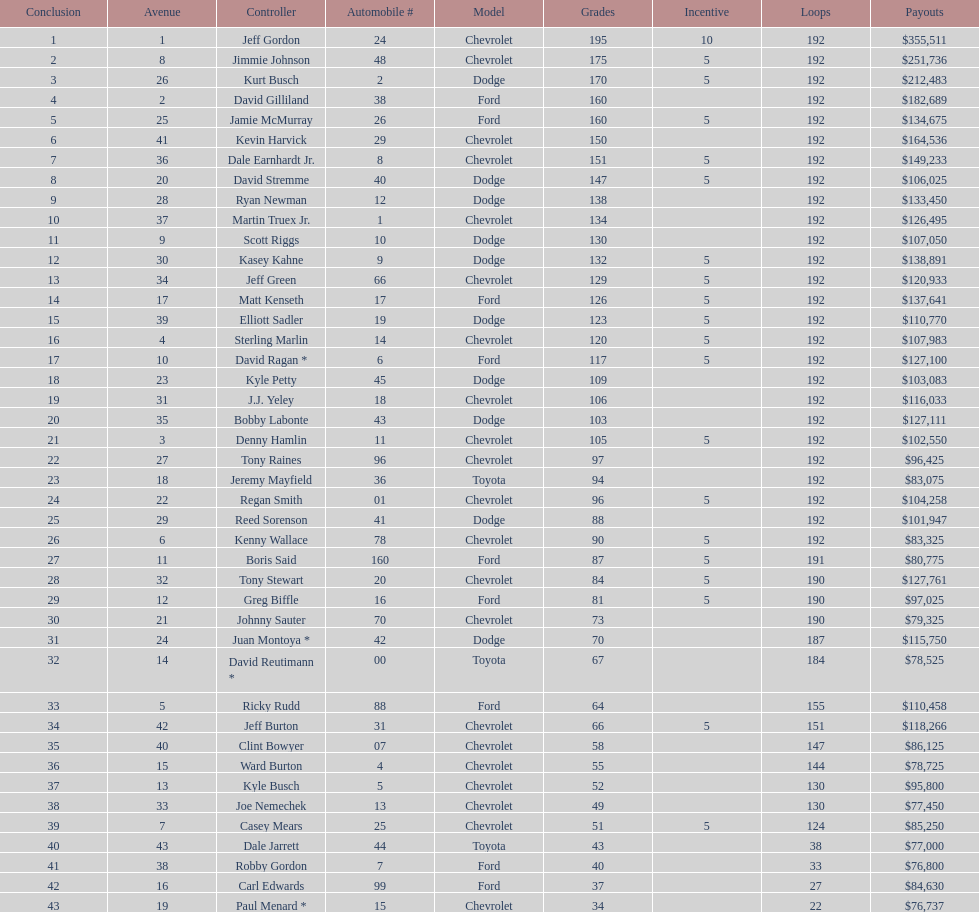How many race car drivers out of the 43 listed drove toyotas? 3. 